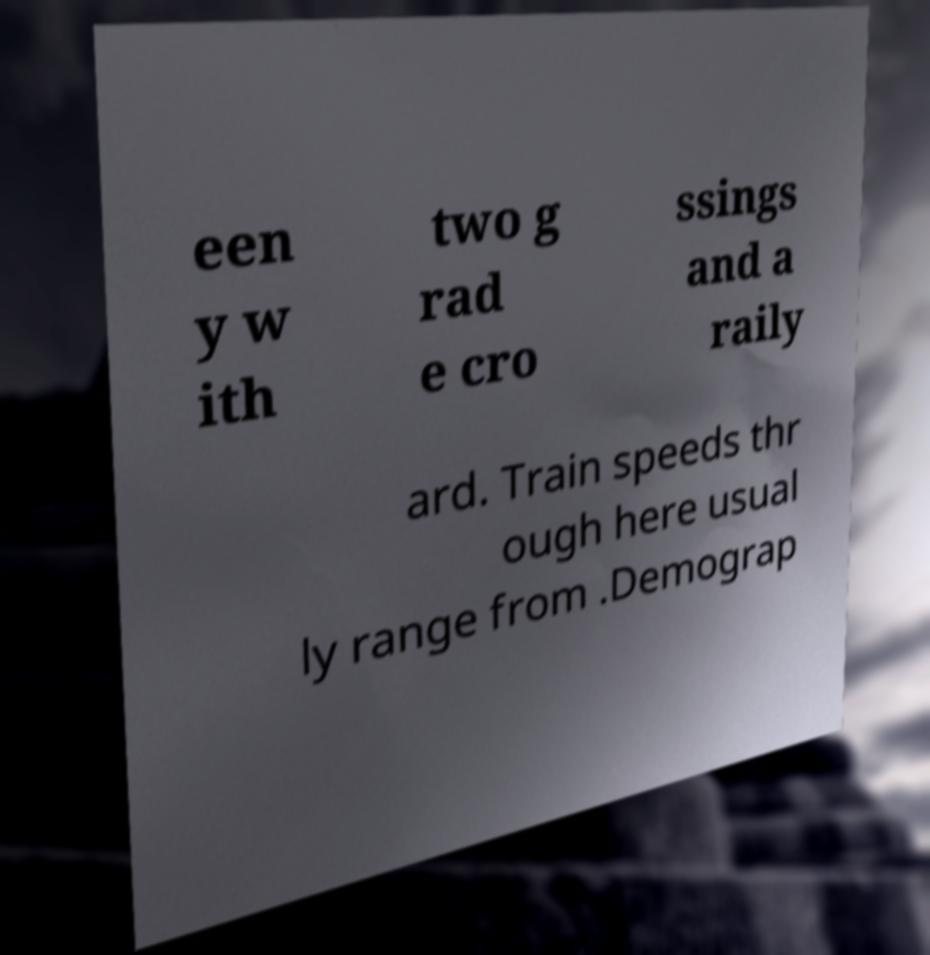I need the written content from this picture converted into text. Can you do that? een y w ith two g rad e cro ssings and a raily ard. Train speeds thr ough here usual ly range from .Demograp 